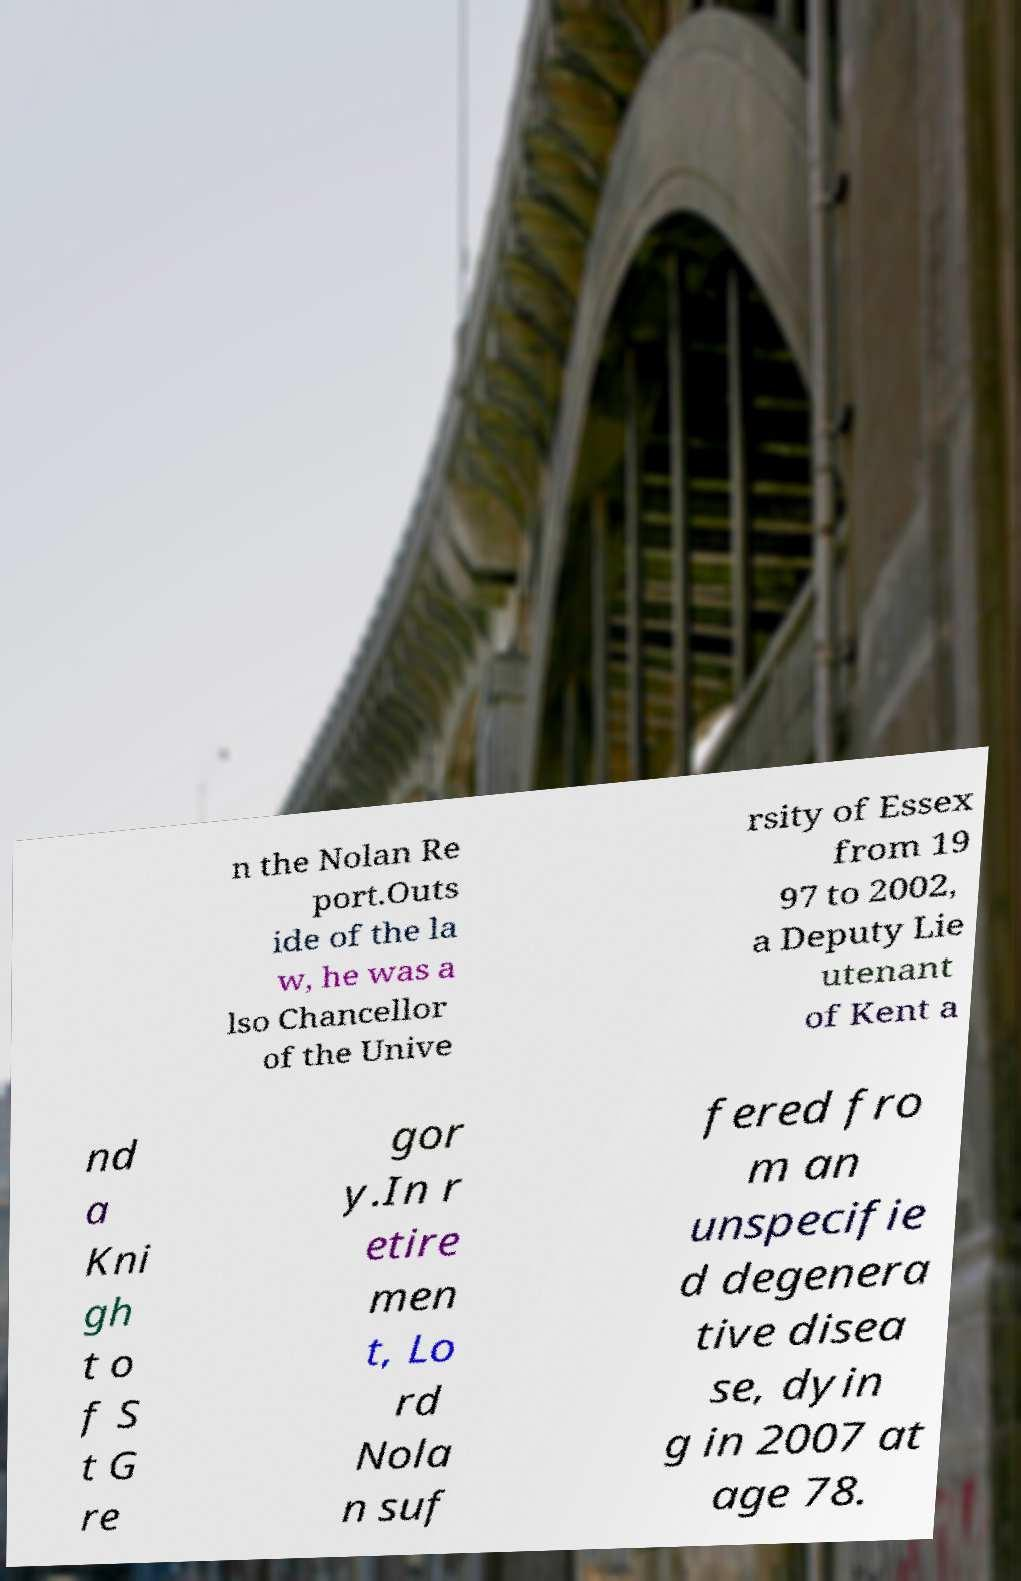For documentation purposes, I need the text within this image transcribed. Could you provide that? n the Nolan Re port.Outs ide of the la w, he was a lso Chancellor of the Unive rsity of Essex from 19 97 to 2002, a Deputy Lie utenant of Kent a nd a Kni gh t o f S t G re gor y.In r etire men t, Lo rd Nola n suf fered fro m an unspecifie d degenera tive disea se, dyin g in 2007 at age 78. 